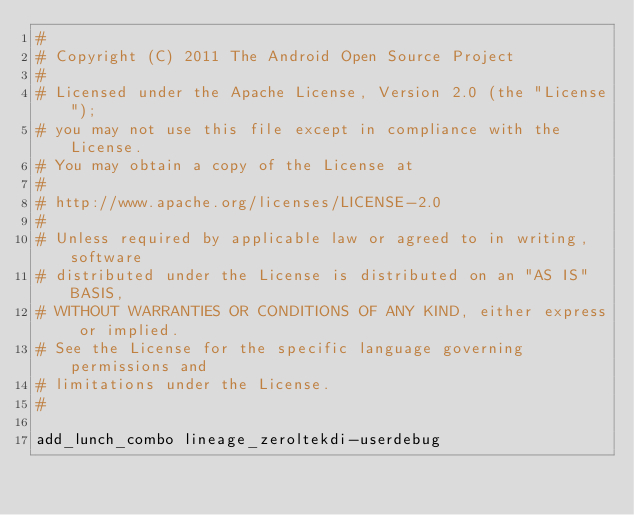<code> <loc_0><loc_0><loc_500><loc_500><_Bash_>#
# Copyright (C) 2011 The Android Open Source Project
#
# Licensed under the Apache License, Version 2.0 (the "License");
# you may not use this file except in compliance with the License.
# You may obtain a copy of the License at
#
# http://www.apache.org/licenses/LICENSE-2.0
#
# Unless required by applicable law or agreed to in writing, software
# distributed under the License is distributed on an "AS IS" BASIS,
# WITHOUT WARRANTIES OR CONDITIONS OF ANY KIND, either express or implied.
# See the License for the specific language governing permissions and
# limitations under the License.
#

add_lunch_combo lineage_zeroltekdi-userdebug</code> 